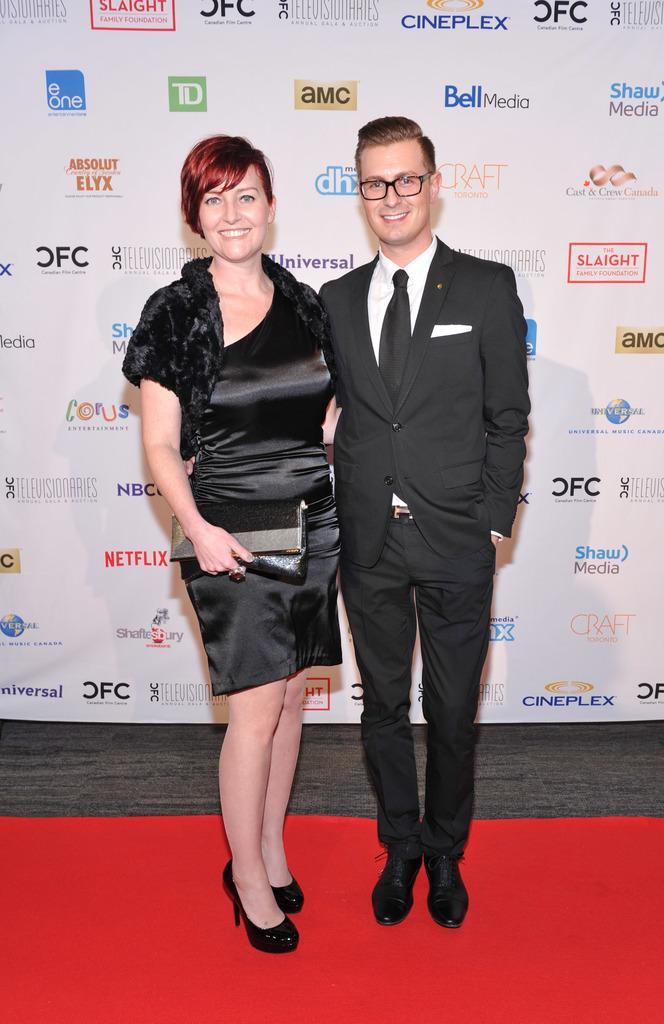Describe this image in one or two sentences. In the background we can see a hoarding. We can see a man and a woman in the black attire and they both are smiling. A woman is holding a purse in her hand and a man wore spectacles. At the bottom we can see a red carpet. 